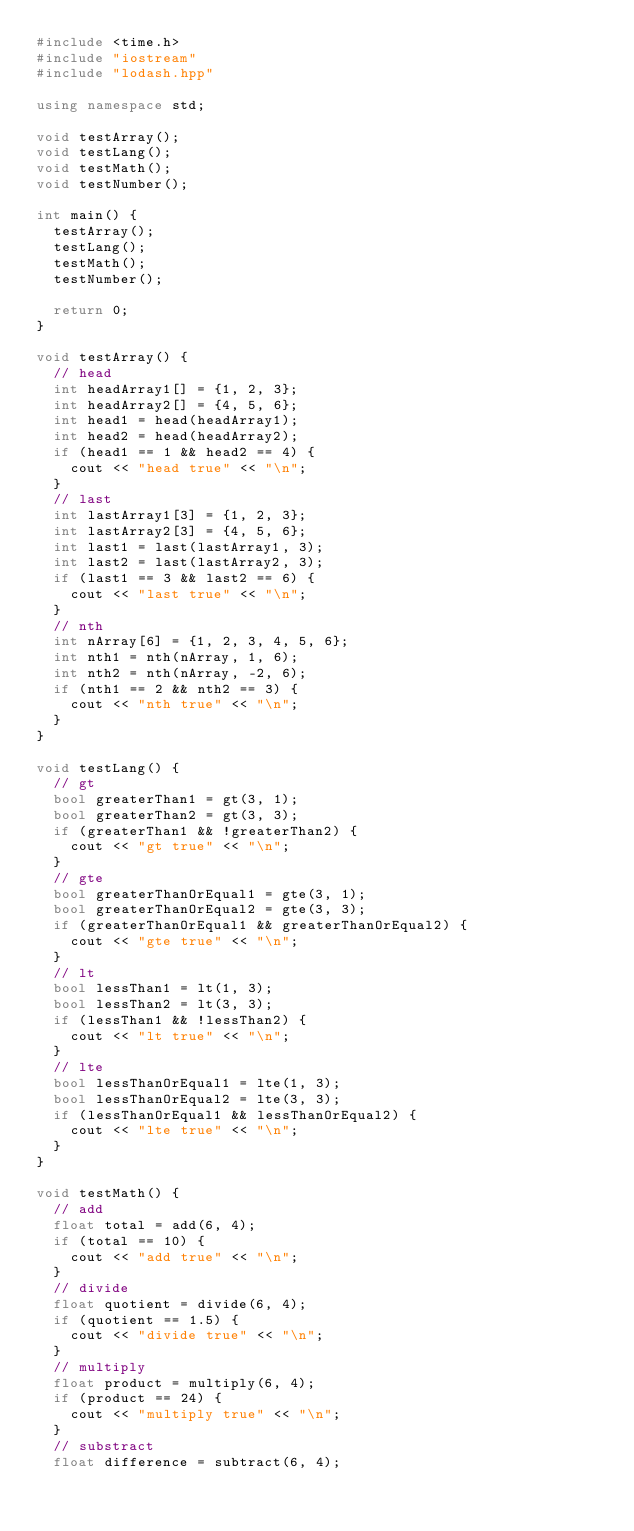<code> <loc_0><loc_0><loc_500><loc_500><_C++_>#include <time.h>
#include "iostream"
#include "lodash.hpp"

using namespace std;

void testArray();
void testLang();
void testMath();
void testNumber();

int main() {
  testArray();
  testLang();
  testMath();
  testNumber();

  return 0;
}

void testArray() {
  // head
  int headArray1[] = {1, 2, 3};
  int headArray2[] = {4, 5, 6};
  int head1 = head(headArray1);
  int head2 = head(headArray2);
  if (head1 == 1 && head2 == 4) {
    cout << "head true" << "\n";
  }
  // last
  int lastArray1[3] = {1, 2, 3};
  int lastArray2[3] = {4, 5, 6};
  int last1 = last(lastArray1, 3);
  int last2 = last(lastArray2, 3);
  if (last1 == 3 && last2 == 6) {
    cout << "last true" << "\n";
  }
  // nth
  int nArray[6] = {1, 2, 3, 4, 5, 6};
  int nth1 = nth(nArray, 1, 6);
  int nth2 = nth(nArray, -2, 6);
  if (nth1 == 2 && nth2 == 3) {
    cout << "nth true" << "\n";
  }
}

void testLang() {
  // gt
	bool greaterThan1 = gt(3, 1);
	bool greaterThan2 = gt(3, 3);
  if (greaterThan1 && !greaterThan2) {
    cout << "gt true" << "\n";
  }
	// gte
	bool greaterThanOrEqual1 = gte(3, 1);
	bool greaterThanOrEqual2 = gte(3, 3);
  if (greaterThanOrEqual1 && greaterThanOrEqual2) {
    cout << "gte true" << "\n";
  }
	// lt
	bool lessThan1 = lt(1, 3);
	bool lessThan2 = lt(3, 3);
  if (lessThan1 && !lessThan2) {
    cout << "lt true" << "\n";
  }
	// lte
	bool lessThanOrEqual1 = lte(1, 3);
	bool lessThanOrEqual2 = lte(3, 3);
  if (lessThanOrEqual1 && lessThanOrEqual2) {
    cout << "lte true" << "\n";
  }
}

void testMath() {
  // add
  float total = add(6, 4);
  if (total == 10) {
    cout << "add true" << "\n";
  }
  // divide
  float quotient = divide(6, 4);
  if (quotient == 1.5) {
    cout << "divide true" << "\n";
  }
  // multiply
  float product = multiply(6, 4);
  if (product == 24) {
    cout << "multiply true" << "\n";
  }
  // substract
  float difference = subtract(6, 4);</code> 